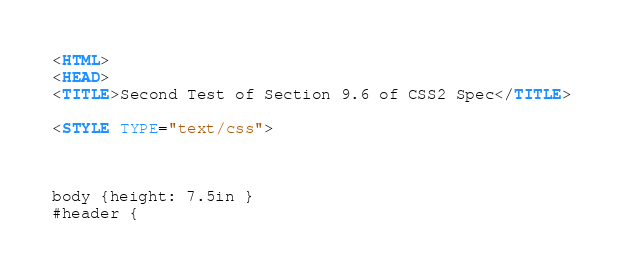Convert code to text. <code><loc_0><loc_0><loc_500><loc_500><_HTML_>

<HTML>
<HEAD>
<TITLE>Second Test of Section 9.6 of CSS2 Spec</TITLE>

<STYLE TYPE="text/css">



body {height: 7.5in }
#header {</code> 